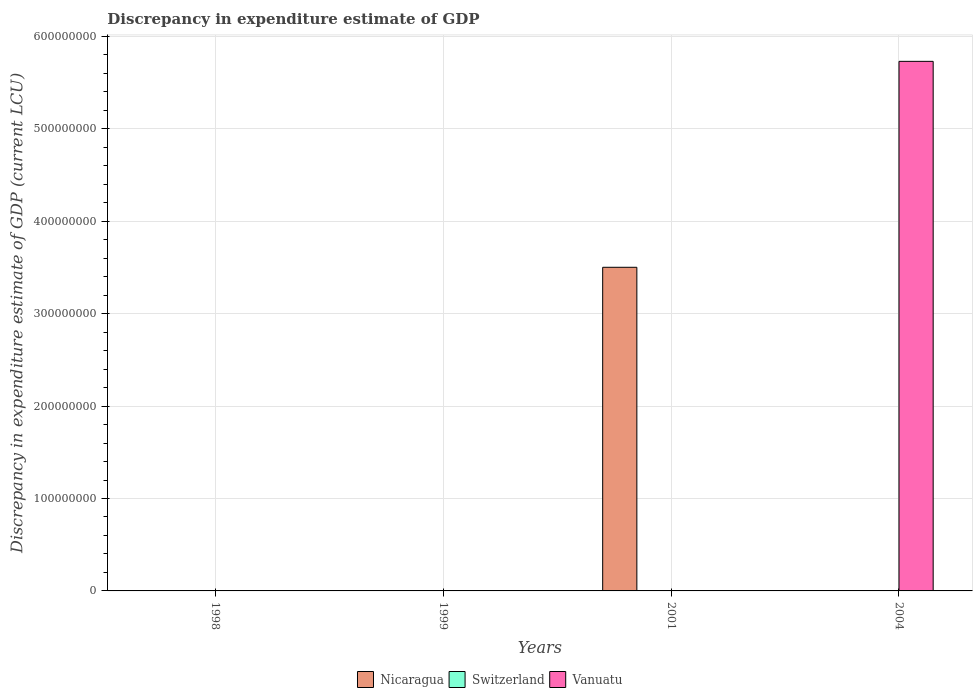How many different coloured bars are there?
Offer a very short reply. 3. How many bars are there on the 1st tick from the right?
Your answer should be very brief. 2. What is the label of the 4th group of bars from the left?
Keep it short and to the point. 2004. In how many cases, is the number of bars for a given year not equal to the number of legend labels?
Offer a terse response. 4. What is the discrepancy in expenditure estimate of GDP in Vanuatu in 1999?
Your answer should be compact. 0. Across all years, what is the maximum discrepancy in expenditure estimate of GDP in Vanuatu?
Provide a succinct answer. 5.73e+08. In which year was the discrepancy in expenditure estimate of GDP in Nicaragua maximum?
Give a very brief answer. 2001. What is the total discrepancy in expenditure estimate of GDP in Nicaragua in the graph?
Give a very brief answer. 3.50e+08. What is the difference between the discrepancy in expenditure estimate of GDP in Nicaragua in 2001 and the discrepancy in expenditure estimate of GDP in Switzerland in 1999?
Provide a short and direct response. 3.50e+08. What is the average discrepancy in expenditure estimate of GDP in Nicaragua per year?
Ensure brevity in your answer.  8.76e+07. In the year 2001, what is the difference between the discrepancy in expenditure estimate of GDP in Switzerland and discrepancy in expenditure estimate of GDP in Nicaragua?
Your response must be concise. -3.50e+08. In how many years, is the discrepancy in expenditure estimate of GDP in Nicaragua greater than 120000000 LCU?
Give a very brief answer. 1. What is the difference between the highest and the lowest discrepancy in expenditure estimate of GDP in Vanuatu?
Offer a terse response. 5.73e+08. In how many years, is the discrepancy in expenditure estimate of GDP in Vanuatu greater than the average discrepancy in expenditure estimate of GDP in Vanuatu taken over all years?
Your answer should be compact. 1. Is it the case that in every year, the sum of the discrepancy in expenditure estimate of GDP in Nicaragua and discrepancy in expenditure estimate of GDP in Vanuatu is greater than the discrepancy in expenditure estimate of GDP in Switzerland?
Give a very brief answer. No. How many legend labels are there?
Keep it short and to the point. 3. What is the title of the graph?
Provide a short and direct response. Discrepancy in expenditure estimate of GDP. What is the label or title of the X-axis?
Ensure brevity in your answer.  Years. What is the label or title of the Y-axis?
Your answer should be compact. Discrepancy in expenditure estimate of GDP (current LCU). What is the Discrepancy in expenditure estimate of GDP (current LCU) in Nicaragua in 1998?
Offer a terse response. 0. What is the Discrepancy in expenditure estimate of GDP (current LCU) of Switzerland in 1998?
Provide a short and direct response. 0. What is the Discrepancy in expenditure estimate of GDP (current LCU) in Vanuatu in 1998?
Offer a very short reply. 0. What is the Discrepancy in expenditure estimate of GDP (current LCU) in Nicaragua in 1999?
Keep it short and to the point. 2.08e+05. What is the Discrepancy in expenditure estimate of GDP (current LCU) in Switzerland in 1999?
Your answer should be compact. 100. What is the Discrepancy in expenditure estimate of GDP (current LCU) in Vanuatu in 1999?
Make the answer very short. 0. What is the Discrepancy in expenditure estimate of GDP (current LCU) in Nicaragua in 2001?
Provide a short and direct response. 3.50e+08. What is the Discrepancy in expenditure estimate of GDP (current LCU) in Switzerland in 2001?
Provide a succinct answer. 100. What is the Discrepancy in expenditure estimate of GDP (current LCU) of Vanuatu in 2001?
Ensure brevity in your answer.  0. What is the Discrepancy in expenditure estimate of GDP (current LCU) in Switzerland in 2004?
Give a very brief answer. 100. What is the Discrepancy in expenditure estimate of GDP (current LCU) of Vanuatu in 2004?
Provide a short and direct response. 5.73e+08. Across all years, what is the maximum Discrepancy in expenditure estimate of GDP (current LCU) of Nicaragua?
Keep it short and to the point. 3.50e+08. Across all years, what is the maximum Discrepancy in expenditure estimate of GDP (current LCU) in Vanuatu?
Provide a succinct answer. 5.73e+08. Across all years, what is the minimum Discrepancy in expenditure estimate of GDP (current LCU) of Nicaragua?
Provide a short and direct response. 0. What is the total Discrepancy in expenditure estimate of GDP (current LCU) in Nicaragua in the graph?
Give a very brief answer. 3.50e+08. What is the total Discrepancy in expenditure estimate of GDP (current LCU) in Switzerland in the graph?
Give a very brief answer. 300. What is the total Discrepancy in expenditure estimate of GDP (current LCU) of Vanuatu in the graph?
Offer a very short reply. 5.73e+08. What is the difference between the Discrepancy in expenditure estimate of GDP (current LCU) in Nicaragua in 1999 and that in 2001?
Give a very brief answer. -3.50e+08. What is the difference between the Discrepancy in expenditure estimate of GDP (current LCU) of Switzerland in 1999 and that in 2001?
Your answer should be compact. 0. What is the difference between the Discrepancy in expenditure estimate of GDP (current LCU) in Switzerland in 2001 and that in 2004?
Provide a short and direct response. 0. What is the difference between the Discrepancy in expenditure estimate of GDP (current LCU) in Nicaragua in 1999 and the Discrepancy in expenditure estimate of GDP (current LCU) in Switzerland in 2001?
Your answer should be compact. 2.08e+05. What is the difference between the Discrepancy in expenditure estimate of GDP (current LCU) in Nicaragua in 1999 and the Discrepancy in expenditure estimate of GDP (current LCU) in Switzerland in 2004?
Make the answer very short. 2.08e+05. What is the difference between the Discrepancy in expenditure estimate of GDP (current LCU) in Nicaragua in 1999 and the Discrepancy in expenditure estimate of GDP (current LCU) in Vanuatu in 2004?
Give a very brief answer. -5.73e+08. What is the difference between the Discrepancy in expenditure estimate of GDP (current LCU) in Switzerland in 1999 and the Discrepancy in expenditure estimate of GDP (current LCU) in Vanuatu in 2004?
Provide a succinct answer. -5.73e+08. What is the difference between the Discrepancy in expenditure estimate of GDP (current LCU) in Nicaragua in 2001 and the Discrepancy in expenditure estimate of GDP (current LCU) in Switzerland in 2004?
Your answer should be very brief. 3.50e+08. What is the difference between the Discrepancy in expenditure estimate of GDP (current LCU) in Nicaragua in 2001 and the Discrepancy in expenditure estimate of GDP (current LCU) in Vanuatu in 2004?
Ensure brevity in your answer.  -2.23e+08. What is the difference between the Discrepancy in expenditure estimate of GDP (current LCU) in Switzerland in 2001 and the Discrepancy in expenditure estimate of GDP (current LCU) in Vanuatu in 2004?
Give a very brief answer. -5.73e+08. What is the average Discrepancy in expenditure estimate of GDP (current LCU) in Nicaragua per year?
Provide a succinct answer. 8.76e+07. What is the average Discrepancy in expenditure estimate of GDP (current LCU) of Vanuatu per year?
Offer a terse response. 1.43e+08. In the year 1999, what is the difference between the Discrepancy in expenditure estimate of GDP (current LCU) of Nicaragua and Discrepancy in expenditure estimate of GDP (current LCU) of Switzerland?
Make the answer very short. 2.08e+05. In the year 2001, what is the difference between the Discrepancy in expenditure estimate of GDP (current LCU) of Nicaragua and Discrepancy in expenditure estimate of GDP (current LCU) of Switzerland?
Your answer should be very brief. 3.50e+08. In the year 2004, what is the difference between the Discrepancy in expenditure estimate of GDP (current LCU) of Switzerland and Discrepancy in expenditure estimate of GDP (current LCU) of Vanuatu?
Your answer should be very brief. -5.73e+08. What is the ratio of the Discrepancy in expenditure estimate of GDP (current LCU) in Nicaragua in 1999 to that in 2001?
Your response must be concise. 0. What is the ratio of the Discrepancy in expenditure estimate of GDP (current LCU) of Switzerland in 1999 to that in 2001?
Offer a very short reply. 1. What is the ratio of the Discrepancy in expenditure estimate of GDP (current LCU) in Switzerland in 1999 to that in 2004?
Provide a short and direct response. 1. What is the difference between the highest and the second highest Discrepancy in expenditure estimate of GDP (current LCU) in Switzerland?
Keep it short and to the point. 0. What is the difference between the highest and the lowest Discrepancy in expenditure estimate of GDP (current LCU) in Nicaragua?
Your answer should be compact. 3.50e+08. What is the difference between the highest and the lowest Discrepancy in expenditure estimate of GDP (current LCU) of Vanuatu?
Provide a succinct answer. 5.73e+08. 